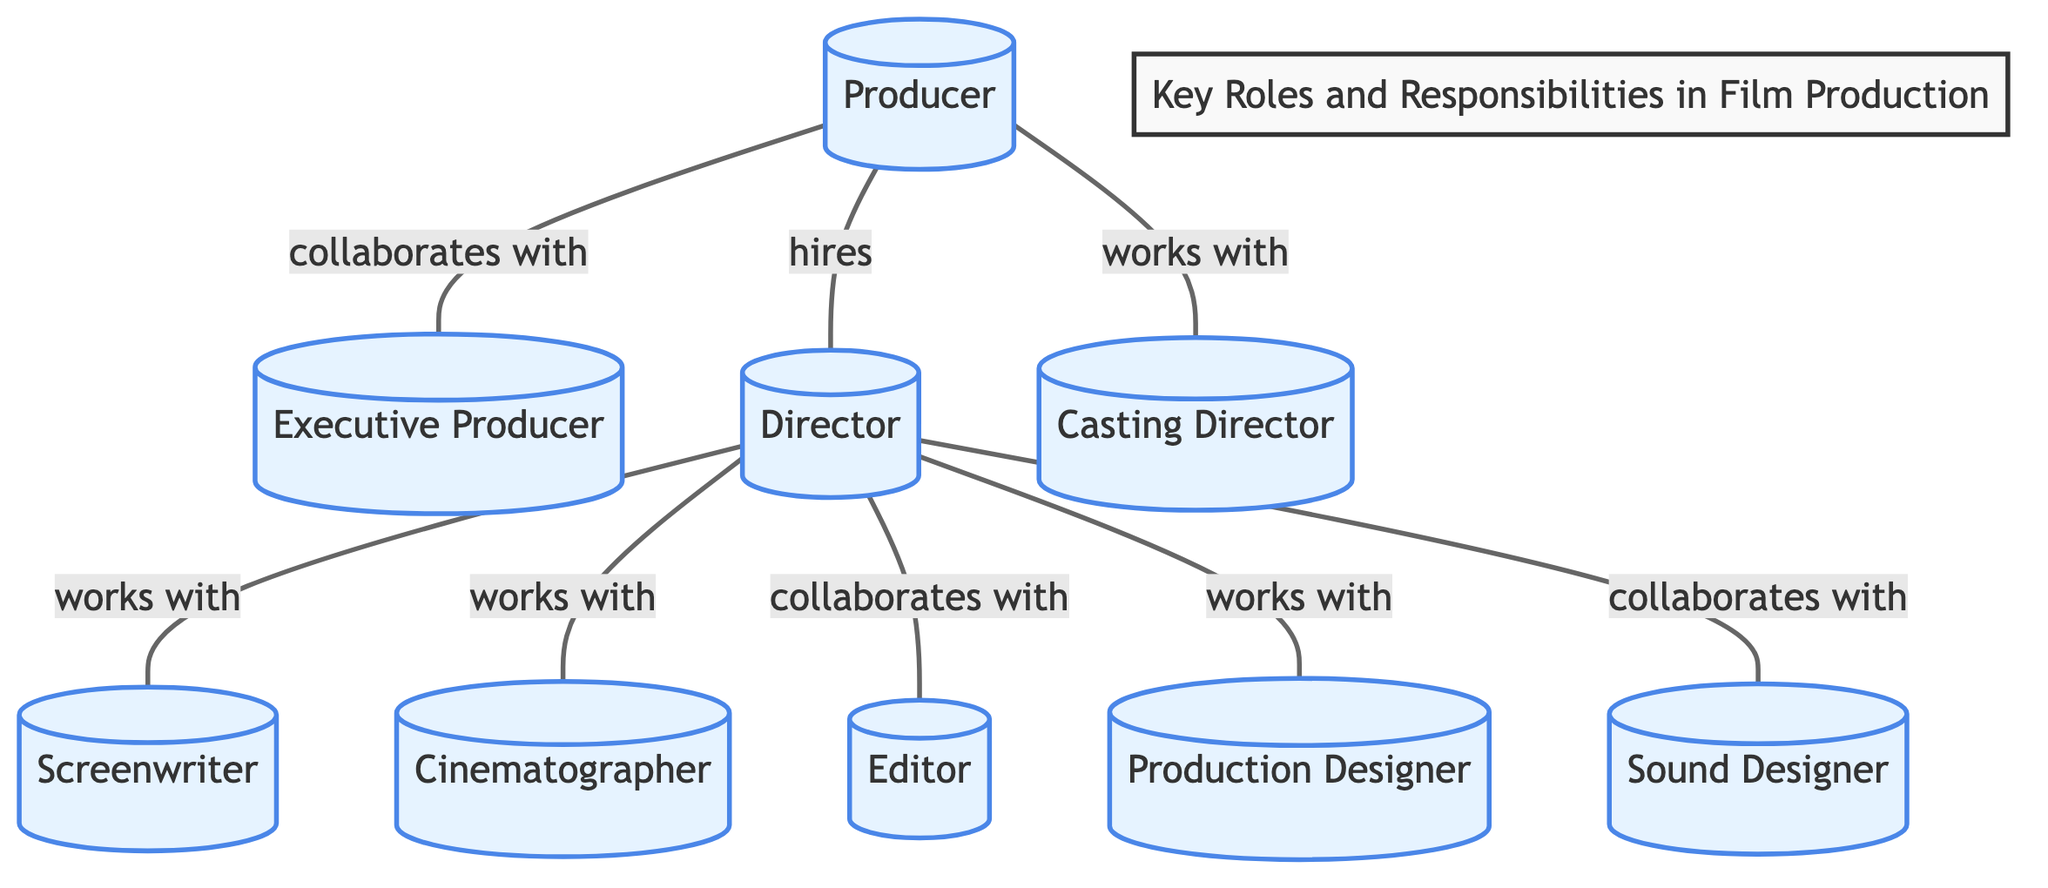What is the primary role of the Producer in film production? The diagram identifies the Producer as the individual who "hires" the Director and "collaborates with" the Executive Producer, indicating that the Producer plays a central role in managing production aspects.
Answer: Producer How many nodes are in the diagram? The diagram includes a total of nine nodes, which represent the key roles involved in film production, including Producer, Executive Producer, Director, Screenwriter, Cinematographer, Editor, Production Designer, Casting Director, and Sound Designer.
Answer: Nine Who does the Director work with to develop the screenplay? According to the diagram, the Director "works with" the Screenwriter, indicating that the Screenwriter is responsible for the screenplay development in collaboration with the Director.
Answer: Screenwriter What connects the Producer and the Casting Director? The diagram shows a line connecting the Producer and the Casting Director, labeled "works with," indicating the relationship of collaboration between these two roles in the film's production process.
Answer: works with How many collaborators does the Director have according to the diagram? The diagram indicates that the Director collaborates with four different roles: Screenwriter, Editor, Production Designer, and Sound Designer, showcasing the interconnectedness of the Director with key creative roles.
Answer: Four Which role has a direct collaboration with both the Producer and Director? Upon reviewing the diagram, the Casting Director is the role that specifically shows a collaboration with the Producer and participation in the hiring process, indicating its dual connection in the production hierarchy.
Answer: Casting Director What is the relationship between the Director and the Cinematographer? The relationship is labeled "works with," indicating that the Director and the Cinematographer collaborate closely to create the visual aspect of the film, highlighting a vital connection in the production process.
Answer: works with What is the relationship label between the Director and the Sound Designer? The diagram highlights the connection between the Director and the Sound Designer as "collaborates with," implying teamwork in crafting the film's audio and sound effects.
Answer: collaborates with How many direct connections does the Producer have in the diagram? The Producer has three direct connections: one to the Executive Producer, one to the Director, and one to the Casting Director, indicating their key collaborative role in the project.
Answer: Three 